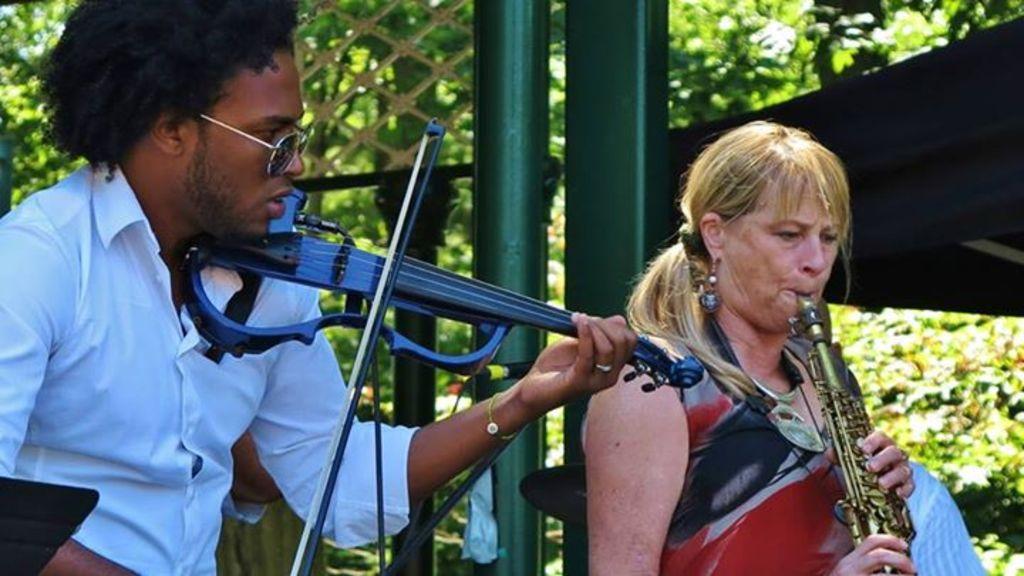How would you summarize this image in a sentence or two? In this image we can see a man wearing the glasses and playing the guitar. We can also see a woman playing the musical instrument. We can see some rods and also the fence. In the background we can see the trees and also the plants. 